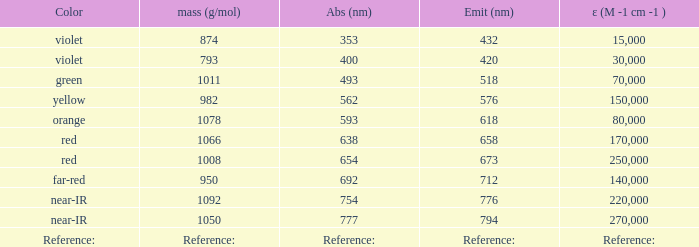Which Emission (in nanometers) that has a molar mass of 1078 g/mol? 618.0. 